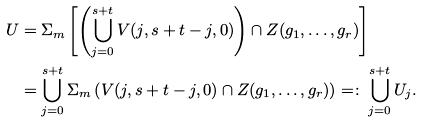Convert formula to latex. <formula><loc_0><loc_0><loc_500><loc_500>U & = \Sigma _ { m } \left [ \left ( \bigcup _ { j = 0 } ^ { s + t } V ( j , s + t - j , 0 ) \right ) \cap Z ( g _ { 1 } , \dots , g _ { r } ) \right ] \\ & = \bigcup _ { j = 0 } ^ { s + t } \Sigma _ { m } \left ( V ( j , s + t - j , 0 ) \cap Z ( g _ { 1 } , \dots , g _ { r } ) \right ) = \colon \bigcup _ { j = 0 } ^ { s + t } U _ { j } .</formula> 